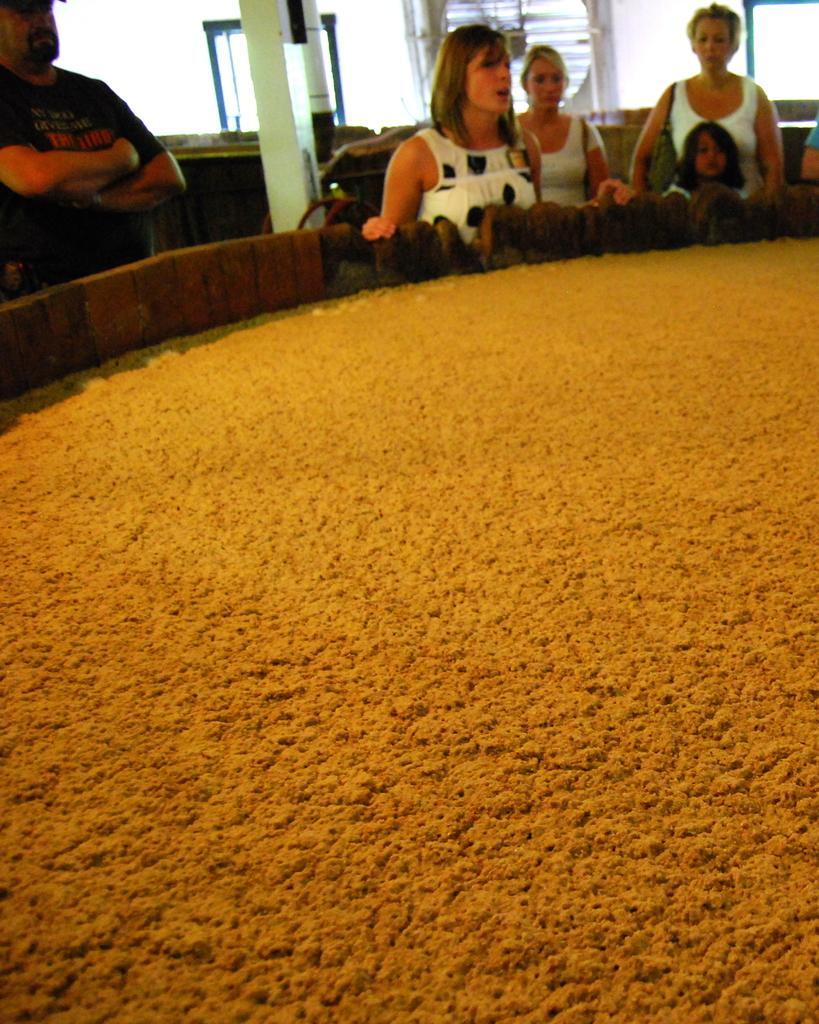What is inside the container in the image? There is food in the container. What are the people in the image doing? The people are standing. What can be seen in the background of the image? There are pillars and windows in the background. What type of credit card is being used by the people in the image? There is no credit card visible in the image, and the people are standing, not using any cards. 